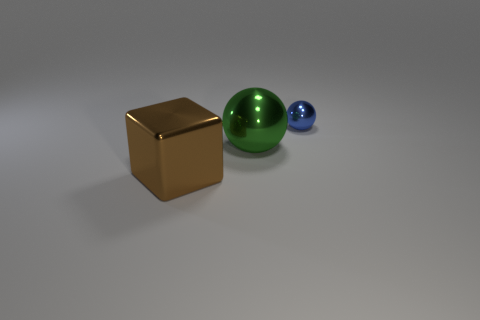Add 2 big green metallic objects. How many objects exist? 5 Subtract all balls. How many objects are left? 1 Subtract all tiny yellow metallic cubes. Subtract all metal objects. How many objects are left? 0 Add 3 metallic objects. How many metallic objects are left? 6 Add 2 big cyan balls. How many big cyan balls exist? 2 Subtract 0 brown balls. How many objects are left? 3 